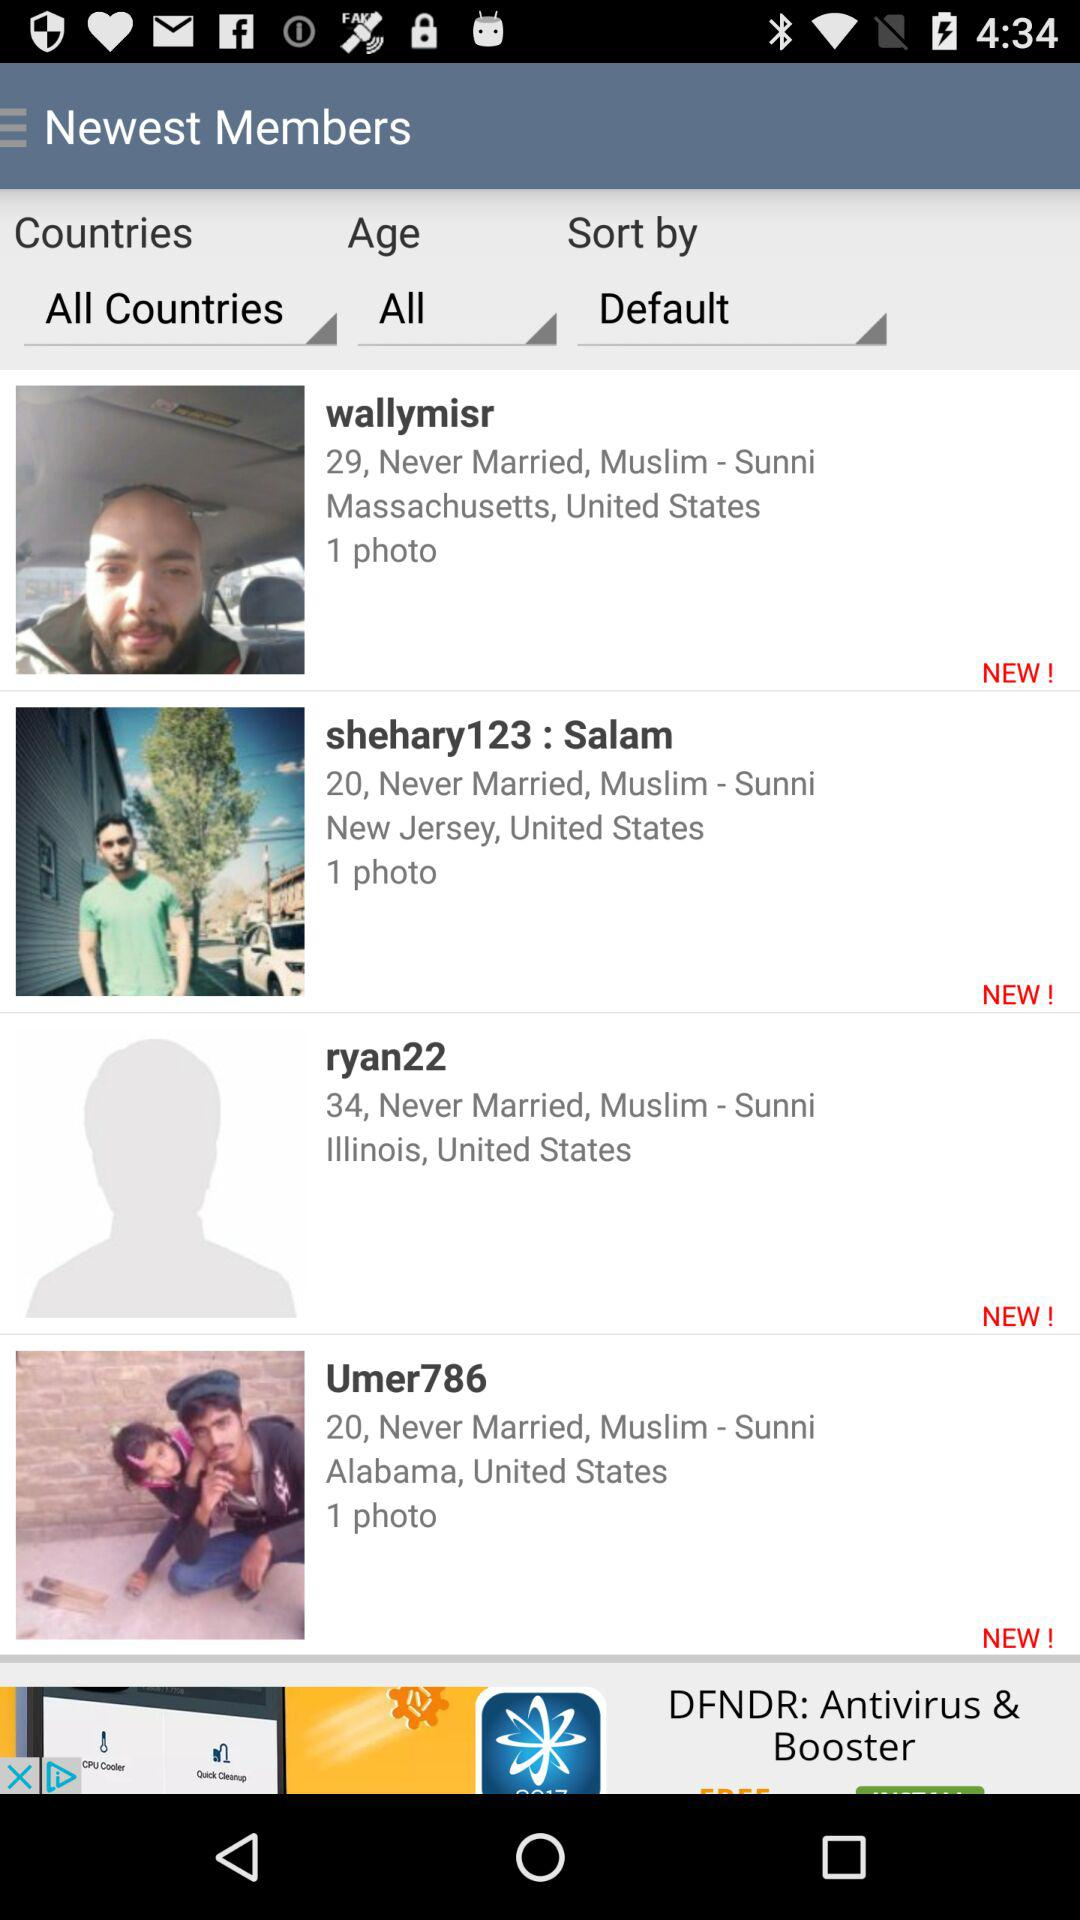What is the location of "ryan22"? The location is Illinois, United States. 